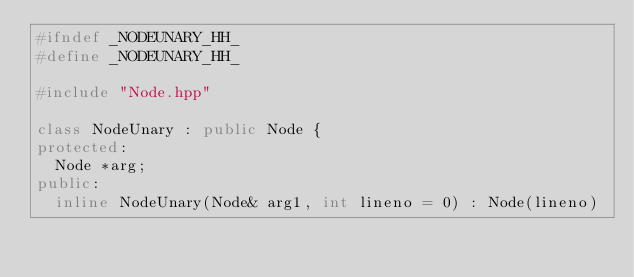<code> <loc_0><loc_0><loc_500><loc_500><_C++_>#ifndef _NODEUNARY_HH_
#define _NODEUNARY_HH_

#include "Node.hpp"

class NodeUnary : public Node {
protected:
	Node *arg;
public:
	inline NodeUnary(Node& arg1, int lineno = 0) : Node(lineno)</code> 